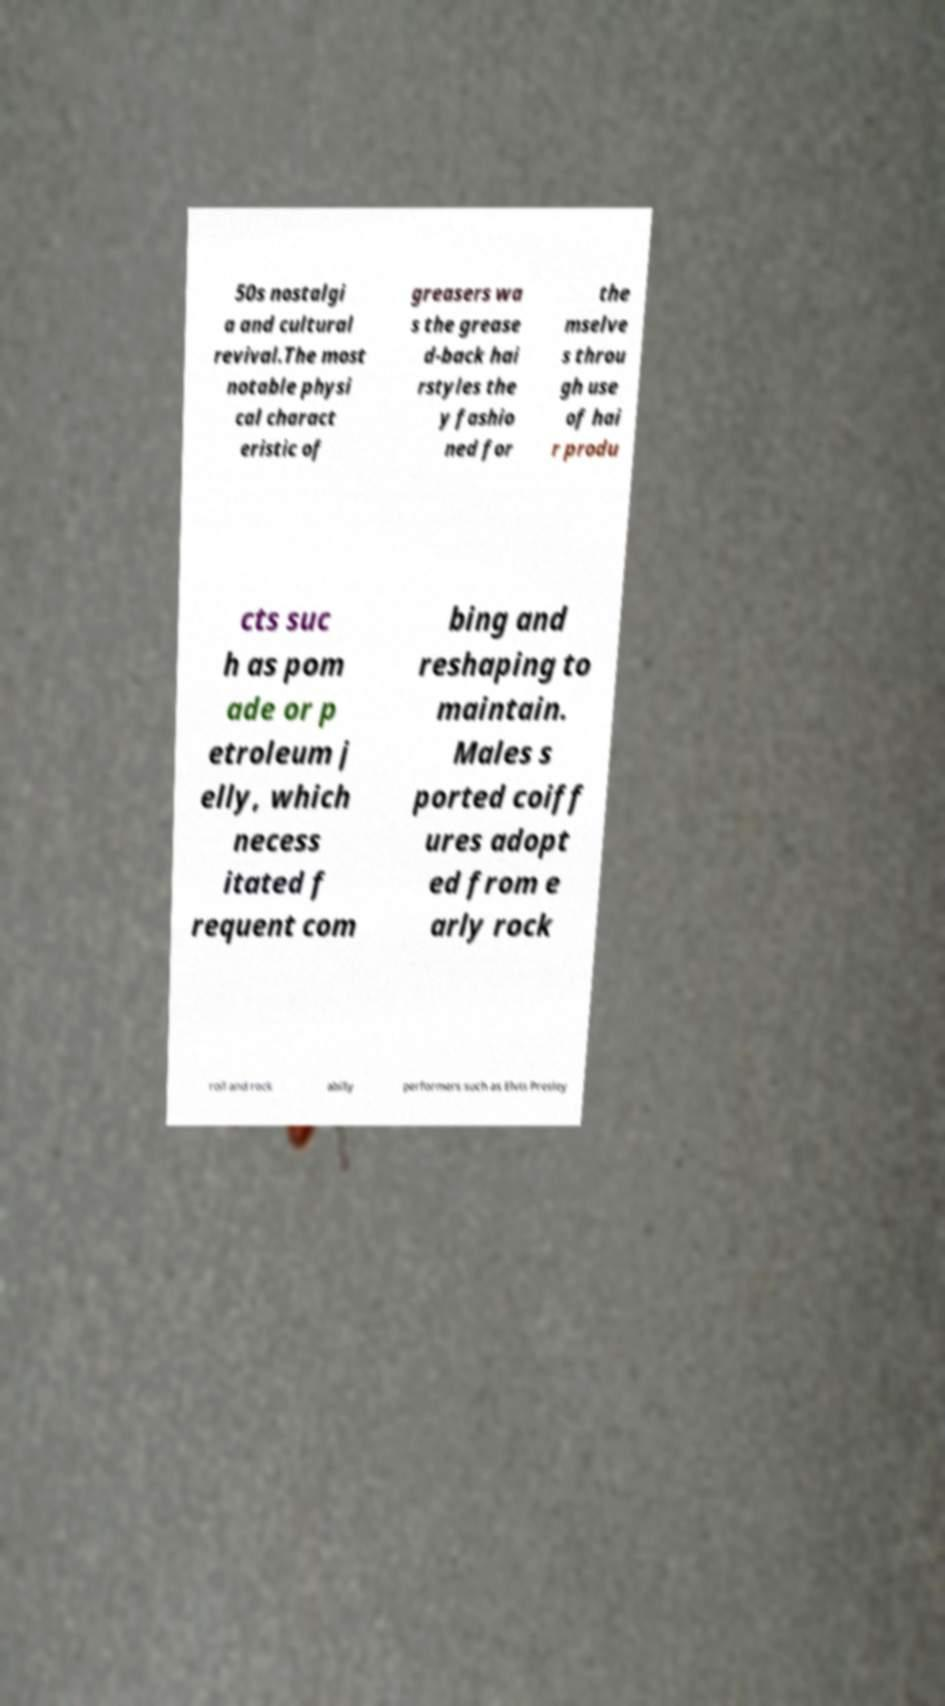Could you extract and type out the text from this image? 50s nostalgi a and cultural revival.The most notable physi cal charact eristic of greasers wa s the grease d-back hai rstyles the y fashio ned for the mselve s throu gh use of hai r produ cts suc h as pom ade or p etroleum j elly, which necess itated f requent com bing and reshaping to maintain. Males s ported coiff ures adopt ed from e arly rock roll and rock abilly performers such as Elvis Presley 